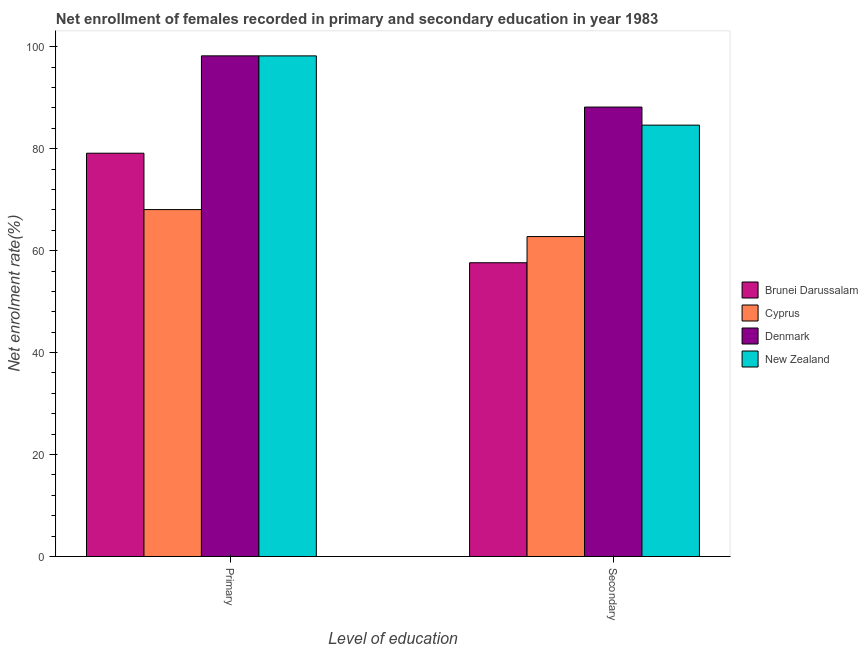How many different coloured bars are there?
Provide a short and direct response. 4. Are the number of bars on each tick of the X-axis equal?
Provide a succinct answer. Yes. What is the label of the 1st group of bars from the left?
Provide a succinct answer. Primary. What is the enrollment rate in secondary education in Denmark?
Your response must be concise. 88.16. Across all countries, what is the maximum enrollment rate in primary education?
Your answer should be compact. 98.21. Across all countries, what is the minimum enrollment rate in primary education?
Your answer should be compact. 68.06. In which country was the enrollment rate in secondary education maximum?
Ensure brevity in your answer.  Denmark. In which country was the enrollment rate in primary education minimum?
Give a very brief answer. Cyprus. What is the total enrollment rate in secondary education in the graph?
Make the answer very short. 293.18. What is the difference between the enrollment rate in primary education in Denmark and that in Cyprus?
Give a very brief answer. 30.15. What is the difference between the enrollment rate in primary education in Brunei Darussalam and the enrollment rate in secondary education in New Zealand?
Offer a very short reply. -5.51. What is the average enrollment rate in primary education per country?
Your answer should be compact. 85.9. What is the difference between the enrollment rate in secondary education and enrollment rate in primary education in Cyprus?
Make the answer very short. -5.29. In how many countries, is the enrollment rate in secondary education greater than 56 %?
Give a very brief answer. 4. What is the ratio of the enrollment rate in primary education in New Zealand to that in Cyprus?
Provide a short and direct response. 1.44. Is the enrollment rate in primary education in Denmark less than that in New Zealand?
Your answer should be very brief. No. What does the 1st bar from the left in Secondary represents?
Make the answer very short. Brunei Darussalam. What does the 3rd bar from the right in Primary represents?
Your answer should be compact. Cyprus. How many countries are there in the graph?
Make the answer very short. 4. Does the graph contain any zero values?
Provide a succinct answer. No. What is the title of the graph?
Provide a succinct answer. Net enrollment of females recorded in primary and secondary education in year 1983. What is the label or title of the X-axis?
Keep it short and to the point. Level of education. What is the label or title of the Y-axis?
Offer a terse response. Net enrolment rate(%). What is the Net enrolment rate(%) of Brunei Darussalam in Primary?
Your answer should be very brief. 79.11. What is the Net enrolment rate(%) in Cyprus in Primary?
Offer a terse response. 68.06. What is the Net enrolment rate(%) in Denmark in Primary?
Your answer should be very brief. 98.21. What is the Net enrolment rate(%) of New Zealand in Primary?
Provide a short and direct response. 98.2. What is the Net enrolment rate(%) in Brunei Darussalam in Secondary?
Provide a succinct answer. 57.63. What is the Net enrolment rate(%) in Cyprus in Secondary?
Provide a succinct answer. 62.77. What is the Net enrolment rate(%) of Denmark in Secondary?
Your response must be concise. 88.16. What is the Net enrolment rate(%) in New Zealand in Secondary?
Your response must be concise. 84.62. Across all Level of education, what is the maximum Net enrolment rate(%) in Brunei Darussalam?
Ensure brevity in your answer.  79.11. Across all Level of education, what is the maximum Net enrolment rate(%) in Cyprus?
Offer a terse response. 68.06. Across all Level of education, what is the maximum Net enrolment rate(%) in Denmark?
Offer a terse response. 98.21. Across all Level of education, what is the maximum Net enrolment rate(%) in New Zealand?
Provide a succinct answer. 98.2. Across all Level of education, what is the minimum Net enrolment rate(%) in Brunei Darussalam?
Offer a terse response. 57.63. Across all Level of education, what is the minimum Net enrolment rate(%) of Cyprus?
Your answer should be very brief. 62.77. Across all Level of education, what is the minimum Net enrolment rate(%) of Denmark?
Ensure brevity in your answer.  88.16. Across all Level of education, what is the minimum Net enrolment rate(%) of New Zealand?
Offer a terse response. 84.62. What is the total Net enrolment rate(%) in Brunei Darussalam in the graph?
Offer a terse response. 136.74. What is the total Net enrolment rate(%) in Cyprus in the graph?
Give a very brief answer. 130.82. What is the total Net enrolment rate(%) in Denmark in the graph?
Your answer should be compact. 186.37. What is the total Net enrolment rate(%) of New Zealand in the graph?
Your answer should be very brief. 182.82. What is the difference between the Net enrolment rate(%) of Brunei Darussalam in Primary and that in Secondary?
Keep it short and to the point. 21.48. What is the difference between the Net enrolment rate(%) of Cyprus in Primary and that in Secondary?
Make the answer very short. 5.29. What is the difference between the Net enrolment rate(%) in Denmark in Primary and that in Secondary?
Your response must be concise. 10.05. What is the difference between the Net enrolment rate(%) of New Zealand in Primary and that in Secondary?
Offer a very short reply. 13.58. What is the difference between the Net enrolment rate(%) of Brunei Darussalam in Primary and the Net enrolment rate(%) of Cyprus in Secondary?
Provide a short and direct response. 16.35. What is the difference between the Net enrolment rate(%) in Brunei Darussalam in Primary and the Net enrolment rate(%) in Denmark in Secondary?
Make the answer very short. -9.05. What is the difference between the Net enrolment rate(%) of Brunei Darussalam in Primary and the Net enrolment rate(%) of New Zealand in Secondary?
Offer a very short reply. -5.51. What is the difference between the Net enrolment rate(%) of Cyprus in Primary and the Net enrolment rate(%) of Denmark in Secondary?
Give a very brief answer. -20.11. What is the difference between the Net enrolment rate(%) of Cyprus in Primary and the Net enrolment rate(%) of New Zealand in Secondary?
Offer a very short reply. -16.56. What is the difference between the Net enrolment rate(%) in Denmark in Primary and the Net enrolment rate(%) in New Zealand in Secondary?
Ensure brevity in your answer.  13.59. What is the average Net enrolment rate(%) in Brunei Darussalam per Level of education?
Make the answer very short. 68.37. What is the average Net enrolment rate(%) of Cyprus per Level of education?
Provide a short and direct response. 65.41. What is the average Net enrolment rate(%) of Denmark per Level of education?
Offer a terse response. 93.19. What is the average Net enrolment rate(%) in New Zealand per Level of education?
Give a very brief answer. 91.41. What is the difference between the Net enrolment rate(%) in Brunei Darussalam and Net enrolment rate(%) in Cyprus in Primary?
Keep it short and to the point. 11.06. What is the difference between the Net enrolment rate(%) in Brunei Darussalam and Net enrolment rate(%) in Denmark in Primary?
Give a very brief answer. -19.1. What is the difference between the Net enrolment rate(%) in Brunei Darussalam and Net enrolment rate(%) in New Zealand in Primary?
Provide a short and direct response. -19.09. What is the difference between the Net enrolment rate(%) in Cyprus and Net enrolment rate(%) in Denmark in Primary?
Your answer should be very brief. -30.15. What is the difference between the Net enrolment rate(%) of Cyprus and Net enrolment rate(%) of New Zealand in Primary?
Your response must be concise. -30.15. What is the difference between the Net enrolment rate(%) of Denmark and Net enrolment rate(%) of New Zealand in Primary?
Ensure brevity in your answer.  0. What is the difference between the Net enrolment rate(%) in Brunei Darussalam and Net enrolment rate(%) in Cyprus in Secondary?
Your answer should be very brief. -5.14. What is the difference between the Net enrolment rate(%) in Brunei Darussalam and Net enrolment rate(%) in Denmark in Secondary?
Your answer should be compact. -30.53. What is the difference between the Net enrolment rate(%) of Brunei Darussalam and Net enrolment rate(%) of New Zealand in Secondary?
Your answer should be compact. -26.99. What is the difference between the Net enrolment rate(%) of Cyprus and Net enrolment rate(%) of Denmark in Secondary?
Give a very brief answer. -25.4. What is the difference between the Net enrolment rate(%) in Cyprus and Net enrolment rate(%) in New Zealand in Secondary?
Keep it short and to the point. -21.85. What is the difference between the Net enrolment rate(%) of Denmark and Net enrolment rate(%) of New Zealand in Secondary?
Offer a very short reply. 3.54. What is the ratio of the Net enrolment rate(%) of Brunei Darussalam in Primary to that in Secondary?
Your response must be concise. 1.37. What is the ratio of the Net enrolment rate(%) in Cyprus in Primary to that in Secondary?
Offer a terse response. 1.08. What is the ratio of the Net enrolment rate(%) of Denmark in Primary to that in Secondary?
Ensure brevity in your answer.  1.11. What is the ratio of the Net enrolment rate(%) of New Zealand in Primary to that in Secondary?
Ensure brevity in your answer.  1.16. What is the difference between the highest and the second highest Net enrolment rate(%) of Brunei Darussalam?
Your response must be concise. 21.48. What is the difference between the highest and the second highest Net enrolment rate(%) of Cyprus?
Your answer should be very brief. 5.29. What is the difference between the highest and the second highest Net enrolment rate(%) of Denmark?
Your answer should be compact. 10.05. What is the difference between the highest and the second highest Net enrolment rate(%) of New Zealand?
Provide a short and direct response. 13.58. What is the difference between the highest and the lowest Net enrolment rate(%) of Brunei Darussalam?
Make the answer very short. 21.48. What is the difference between the highest and the lowest Net enrolment rate(%) of Cyprus?
Provide a succinct answer. 5.29. What is the difference between the highest and the lowest Net enrolment rate(%) of Denmark?
Your response must be concise. 10.05. What is the difference between the highest and the lowest Net enrolment rate(%) of New Zealand?
Ensure brevity in your answer.  13.58. 